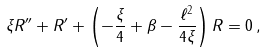<formula> <loc_0><loc_0><loc_500><loc_500>\xi R ^ { \prime \prime } + R ^ { \prime } + \left ( - \frac { \xi } { 4 } + \beta - \frac { \ell ^ { 2 } } { 4 \xi } \right ) R = 0 \, ,</formula> 